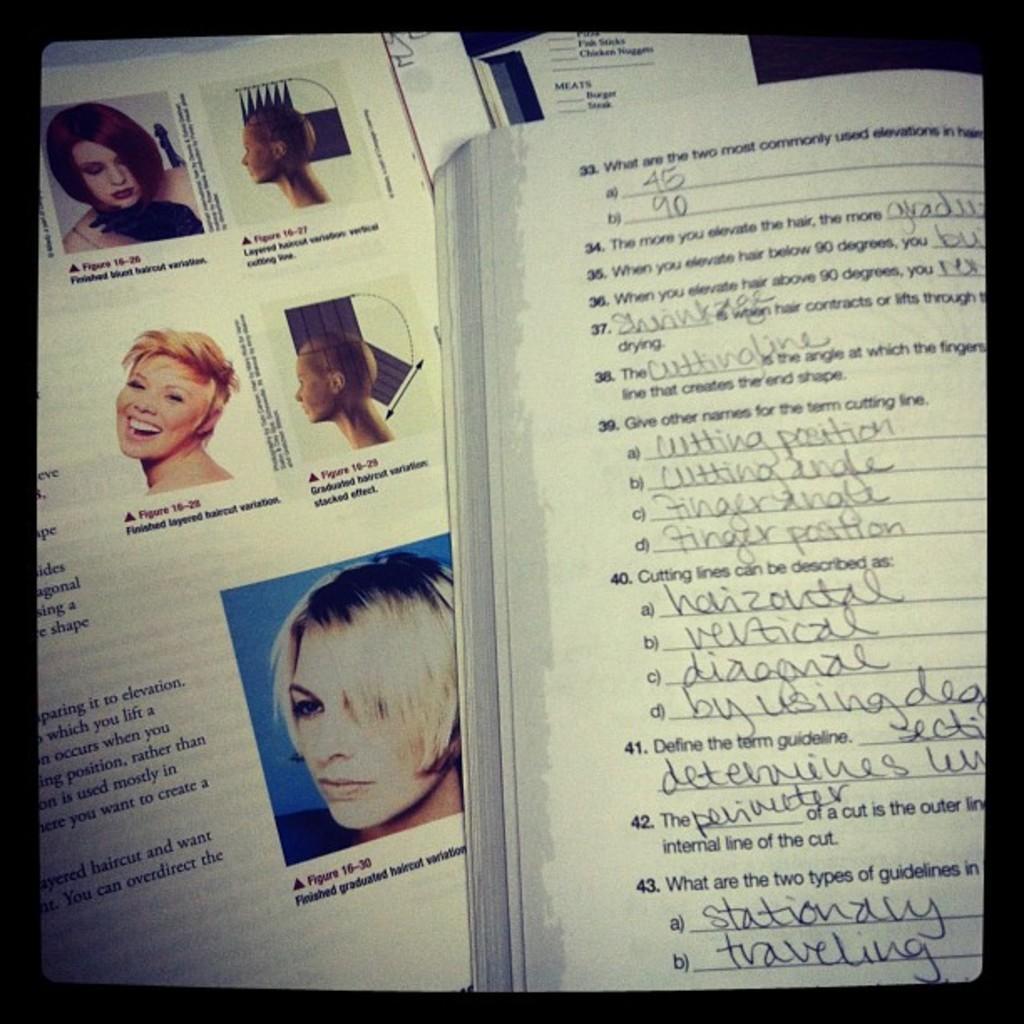Can you describe this image briefly? On the right side, we see a book with some text written on it. On the left side, we see the paper containing the images of women and we even see some text written on it. This picture might be an edited image. 